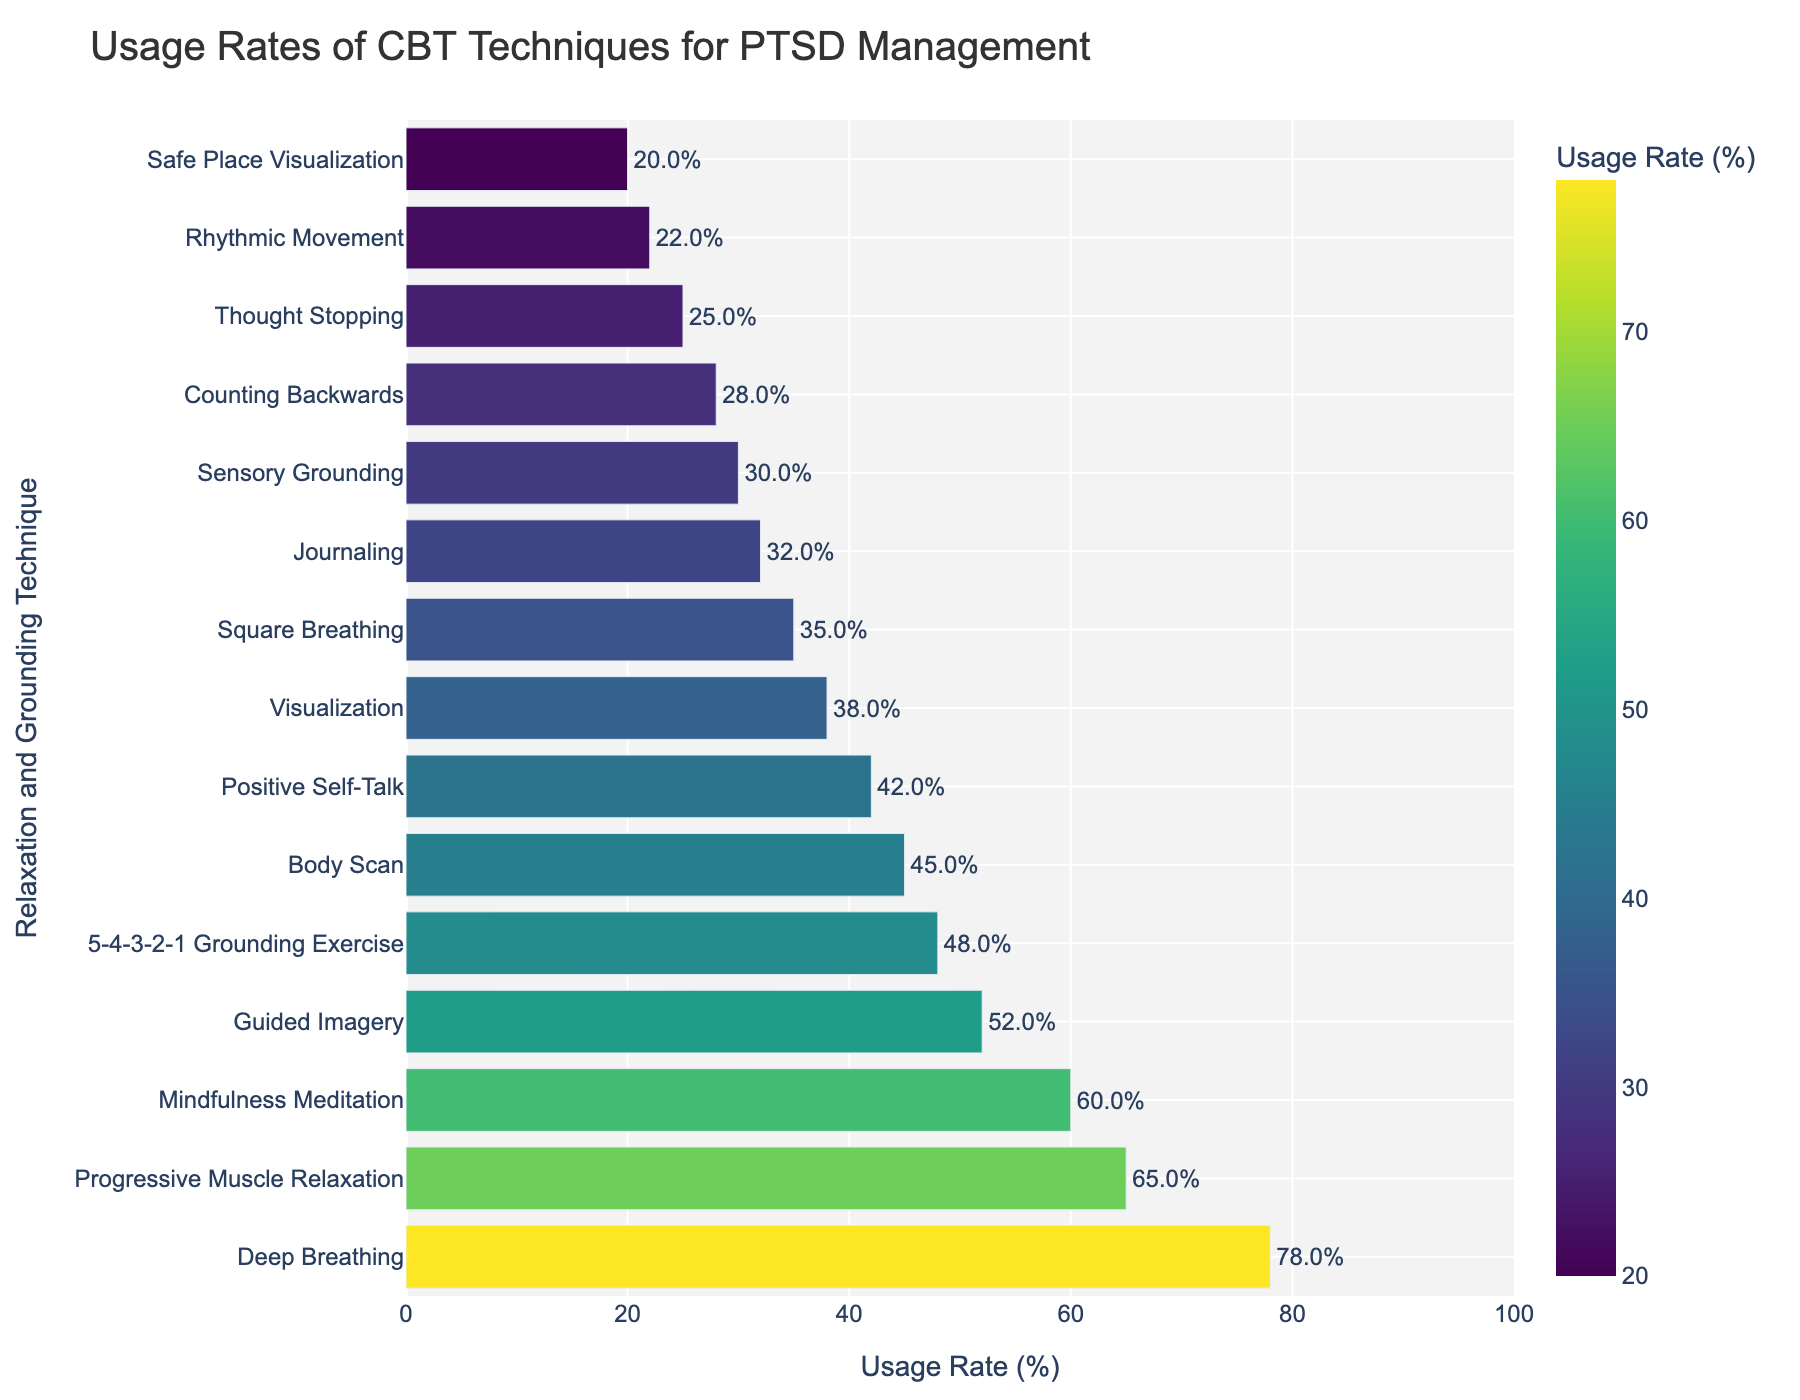What is the usage rate of Deep Breathing? Referring to the highest bar, the bar for Deep Breathing shows a value of 78%.
Answer: 78% Which technique has the lowest usage rate, and what is it? The shortest bar corresponds to Safe Place Visualization, which has a usage rate of 20%.
Answer: Safe Place Visualization, 20% Between Progressive Muscle Relaxation and Positive Self-Talk, which technique has a higher usage rate, and by how much? The bar for Progressive Muscle Relaxation is higher at 65%, and the bar for Positive Self-Talk is 42%. The difference is 65% - 42% = 23%.
Answer: Progressive Muscle Relaxation by 23% How many techniques have a usage rate of 50% or higher? Techniques with bars that reach or exceed the 50% mark are: Deep Breathing (78%), Progressive Muscle Relaxation (65%), Mindfulness Meditation (60%), and Guided Imagery (52%). That's a total of four techniques.
Answer: 4 What's the average usage rate of the three least used techniques? The three least used techniques are Safe Place Visualization (20%), Rhythmic Movement (22%), and Thought Stopping (25%). The average is (20% + 22% + 25%) / 3 = 22.33%.
Answer: 22.33% What is the combined usage rate of Guided Imagery and 5-4-3-2-1 Grounding Exercise? Add the usage rates of Guided Imagery (52%) and 5-4-3-2-1 Grounding Exercise (48%) to get 52% + 48% = 100%.
Answer: 100% Which technique has a usage rate most similar to Mindfulness Meditation? The bar closest in height to Mindfulness Meditation (60%) is Guided Imagery at 52%, making it the most similar.
Answer: Guided Imagery What is the difference in usage rates between the most and the least used technique? The highest usage rate is for Deep Breathing at 78%, and the lowest is for Safe Place Visualization at 20%. The difference is 78% - 20% = 58%.
Answer: 58% How does the usage rate of Journaling compare to Visualization? The bar for Journaling shows a usage rate of 32%, while Visualization has a usage rate of 38%. Therefore, Visualization has a higher usage rate by 38% - 32% = 6%.
Answer: Visualization by 6% 